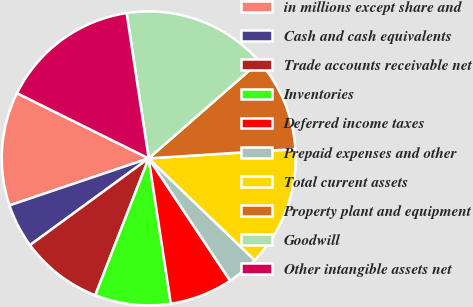Convert chart. <chart><loc_0><loc_0><loc_500><loc_500><pie_chart><fcel>in millions except share and<fcel>Cash and cash equivalents<fcel>Trade accounts receivable net<fcel>Inventories<fcel>Deferred income taxes<fcel>Prepaid expenses and other<fcel>Total current assets<fcel>Property plant and equipment<fcel>Goodwill<fcel>Other intangible assets net<nl><fcel>12.5%<fcel>4.86%<fcel>9.03%<fcel>8.33%<fcel>6.94%<fcel>3.47%<fcel>13.19%<fcel>10.42%<fcel>15.97%<fcel>15.28%<nl></chart> 